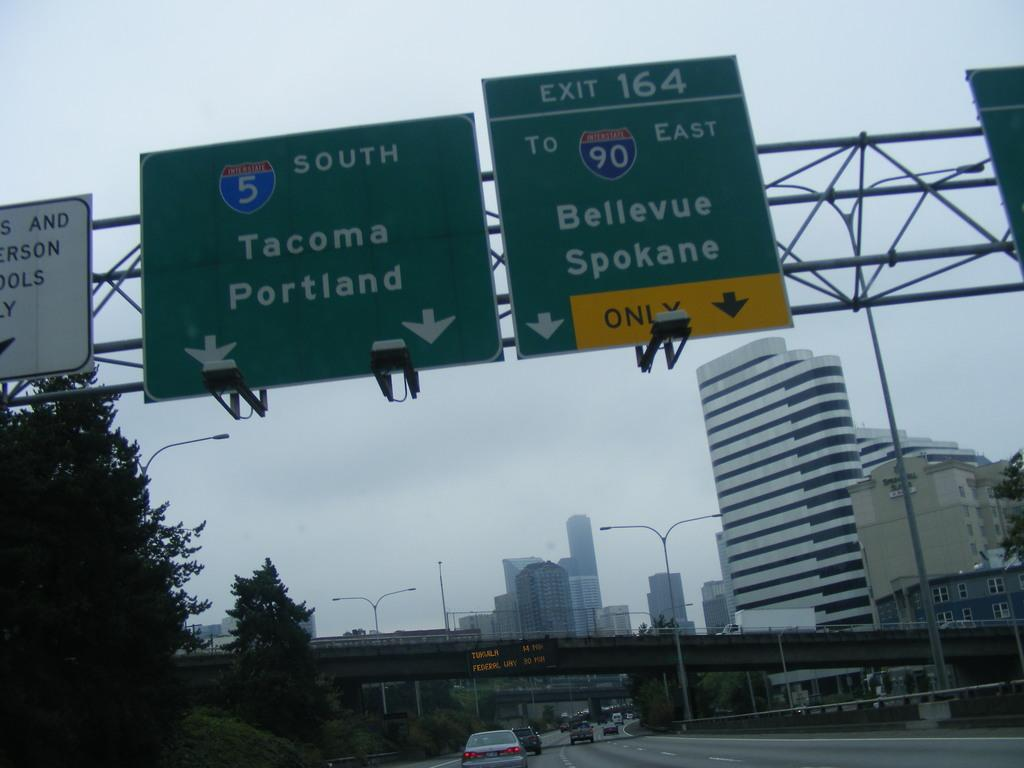<image>
Render a clear and concise summary of the photo. Highway signs point towards the cities of Portland, Tacoma, Bellevue and Spokane. 